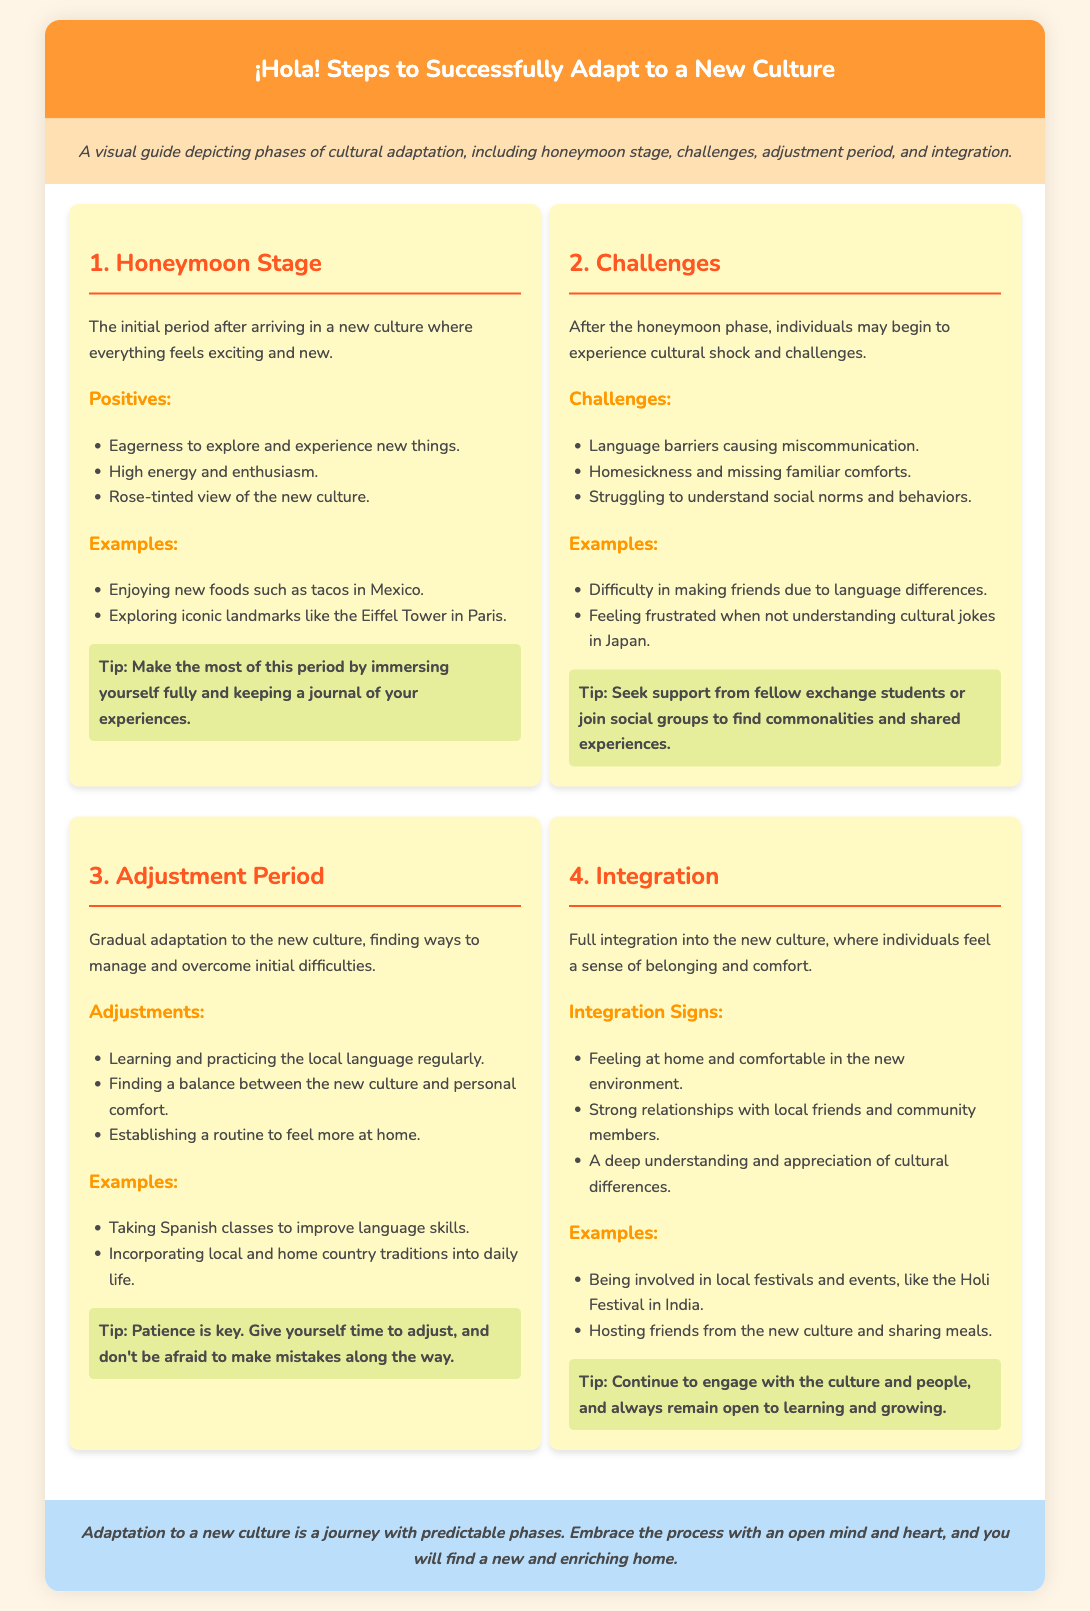What is the first stage of cultural adaptation? The document lists the first stage as the Honeymoon Stage.
Answer: Honeymoon Stage What are two positives of the Honeymoon Stage? The document mentions eagerness to explore and high energy and enthusiasm as positives of this stage.
Answer: Eagerness to explore, high energy What challenges are faced in the second stage? The challenges outlined in the document include language barriers and homesickness.
Answer: Language barriers, homesickness What period comes after the Challenges stage? The document indicates that the Adjustment Period follows the Challenges stage.
Answer: Adjustment Period Name one adjustment mentioned in the Adjustment Period. The document states that learning and practicing the local language regularly is one adjustment mentioned.
Answer: Learning and practicing the local language What is a sign of Integration into a new culture? The document lists feeling at home and comfortable as a sign of Integration.
Answer: Feeling at home What is one example of integration mentioned? Hosting friends from the new culture and sharing meals is given as an example in the document.
Answer: Hosting friends and sharing meals What tip is given for the Honeymoon Stage? The document suggests immersing oneself fully and keeping a journal of experiences.
Answer: Immersing fully and keeping a journal How many stages of cultural adaptation are described? The document outlines a total of four stages of cultural adaptation.
Answer: Four stages 